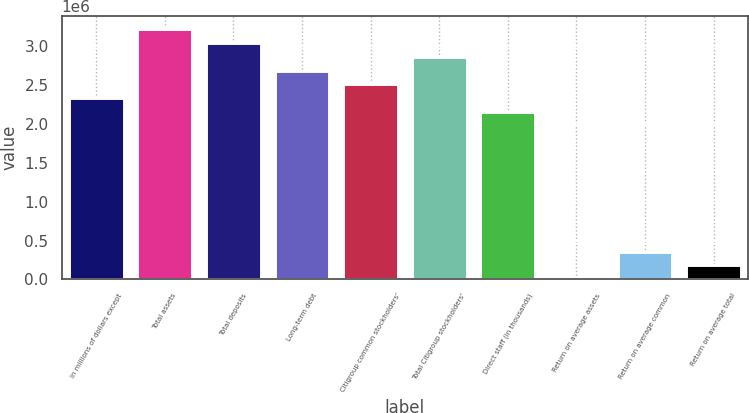Convert chart. <chart><loc_0><loc_0><loc_500><loc_500><bar_chart><fcel>In millions of dollars except<fcel>Total assets<fcel>Total deposits<fcel>Long-term debt<fcel>Citigroup common stockholders'<fcel>Total Citigroup stockholders'<fcel>Direct staff (in thousands)<fcel>Return on average assets<fcel>Return on average common<fcel>Return on average total<nl><fcel>2.3297e+06<fcel>3.22574e+06<fcel>3.04653e+06<fcel>2.68812e+06<fcel>2.50891e+06<fcel>2.86732e+06<fcel>2.15049e+06<fcel>0.82<fcel>358416<fcel>179208<nl></chart> 